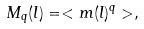<formula> <loc_0><loc_0><loc_500><loc_500>M _ { q } ( l ) = < m ( l ) ^ { q } > ,</formula> 